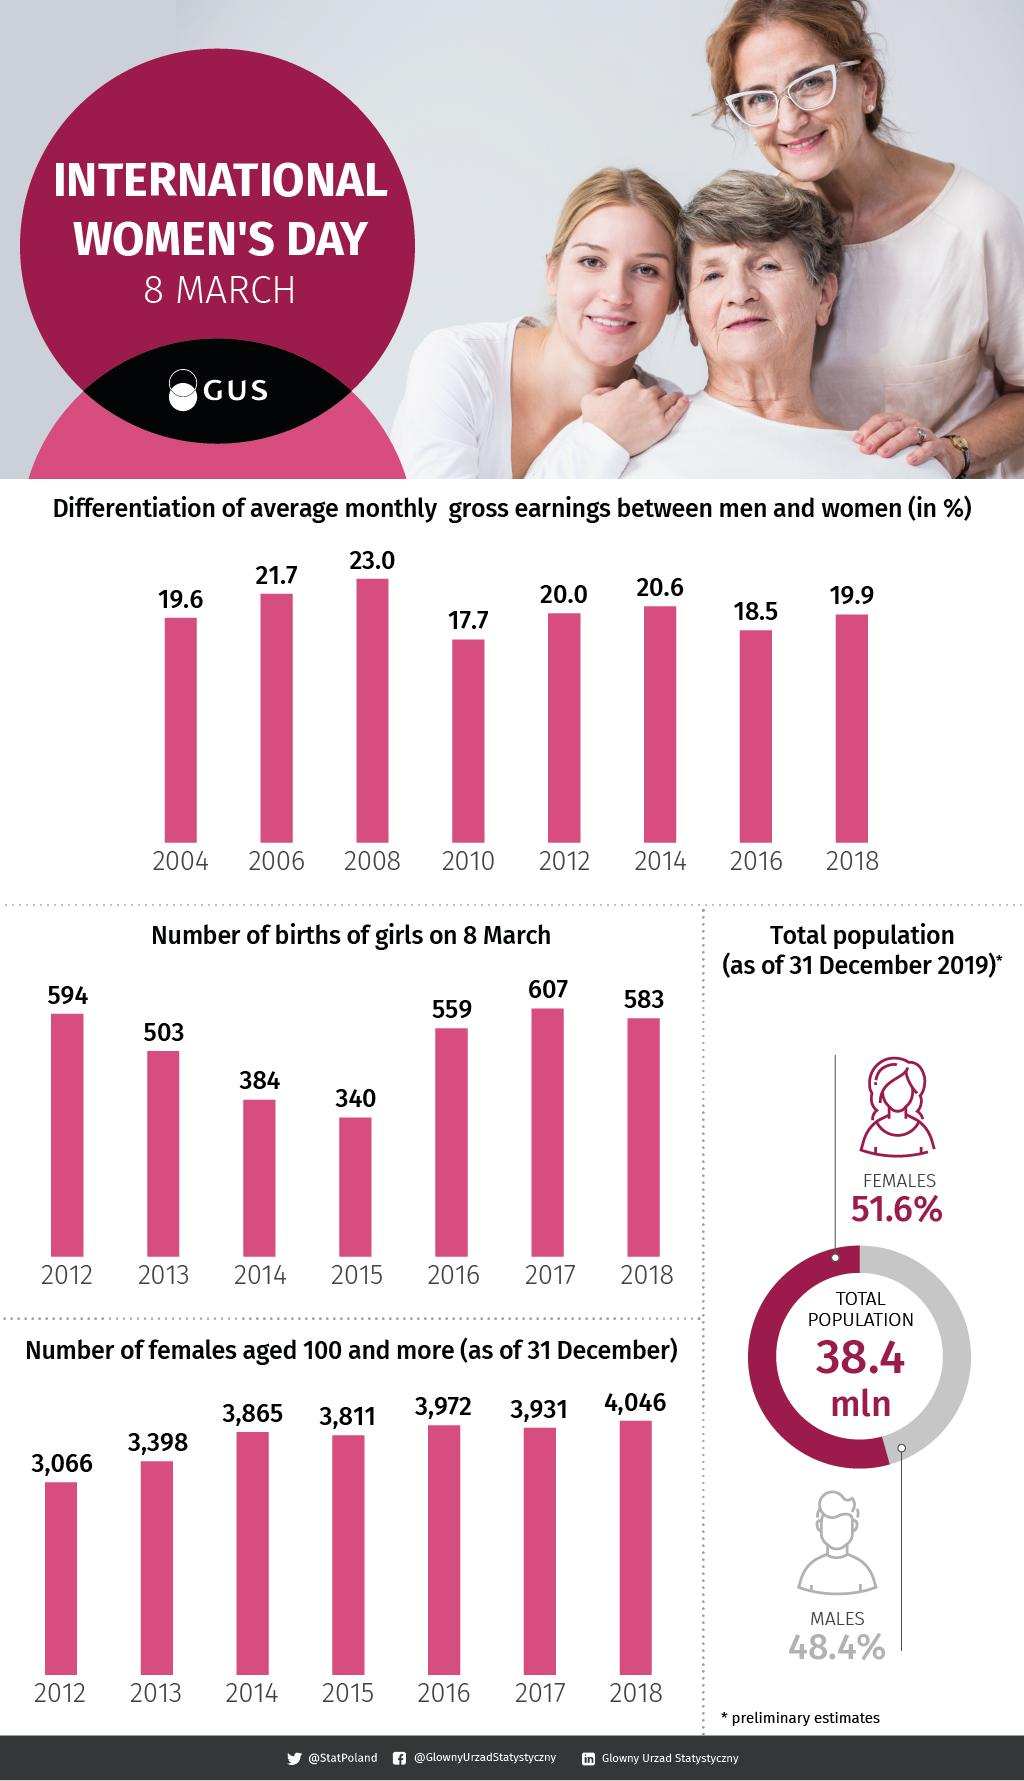Indicate a few pertinent items in this graphic. In 2012 and 2013, there were 6,464 females who were 100 years old or older. In 2014 and 2015, the number of births of girls on March 8 combined was 724. There were a total of 1097 births of girls in March 8th in both 2012 and 2013 combined. In 2016 and 2017, the total number of births of girls on March 8 was 1166. In 2014 and 2015, the number of females aged 100 and above was 7,676. 